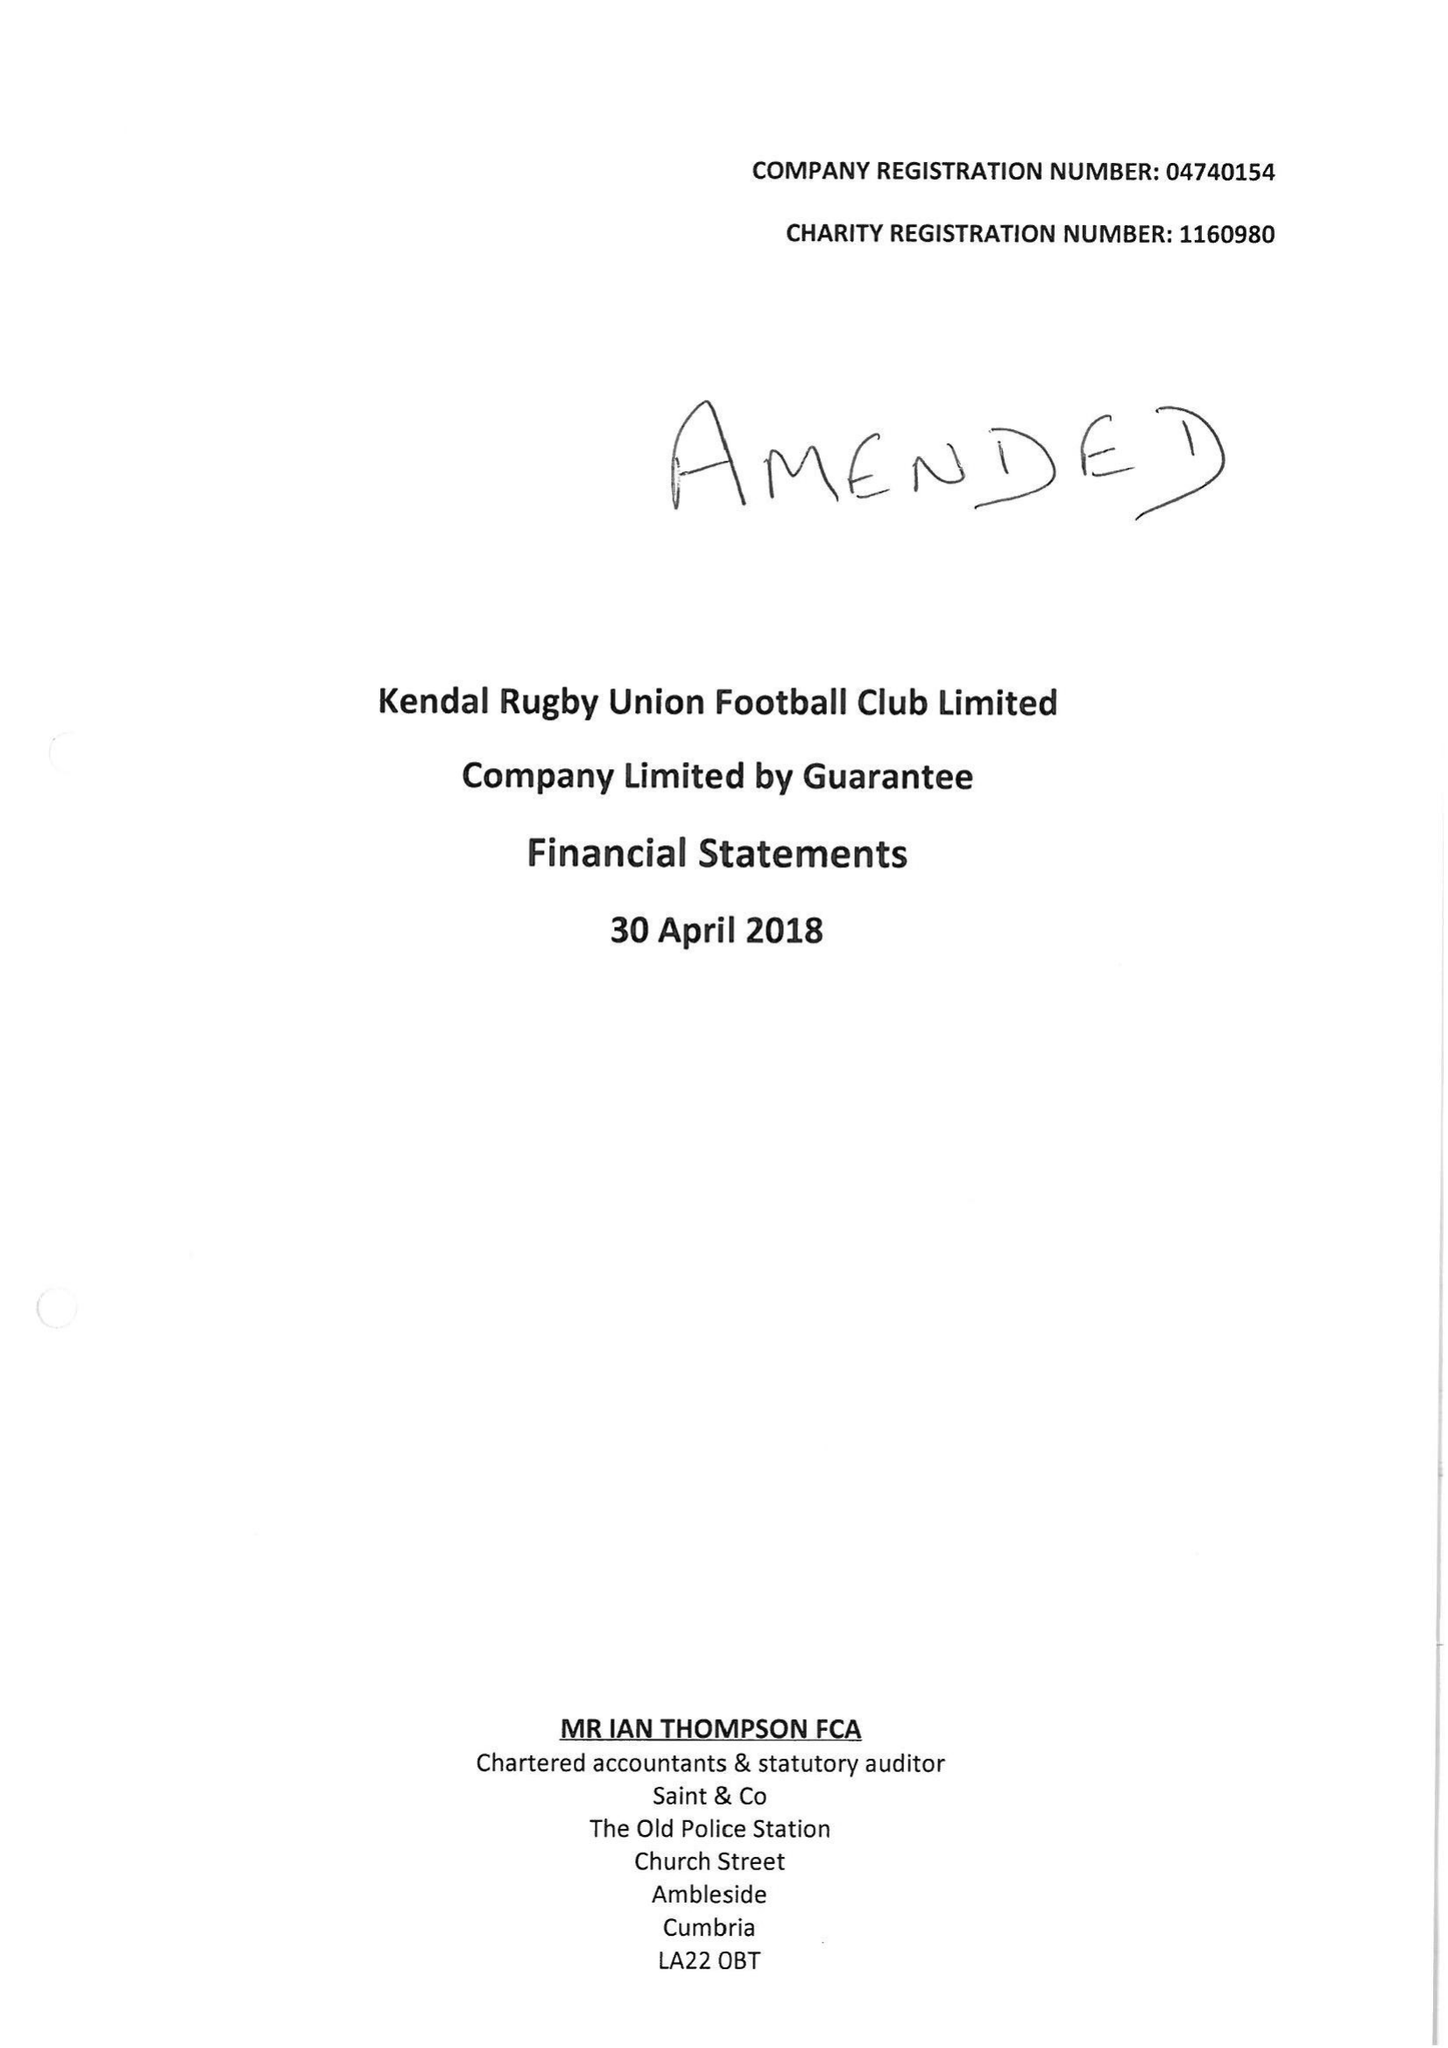What is the value for the address__postcode?
Answer the question using a single word or phrase. LA9 6NY 